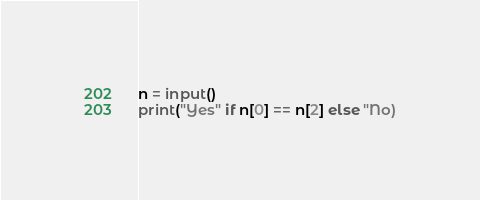<code> <loc_0><loc_0><loc_500><loc_500><_Python_>n = input()
print("Yes" if n[0] == n[2] else "No)</code> 